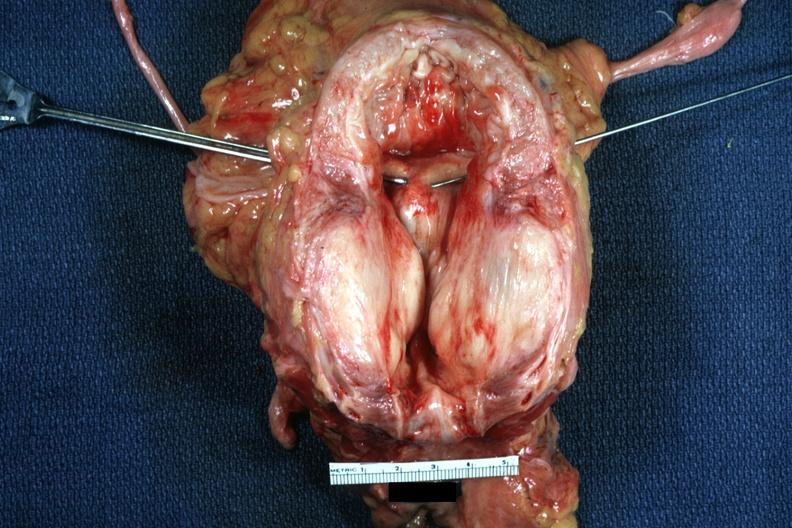s hyperplasia present?
Answer the question using a single word or phrase. Yes 